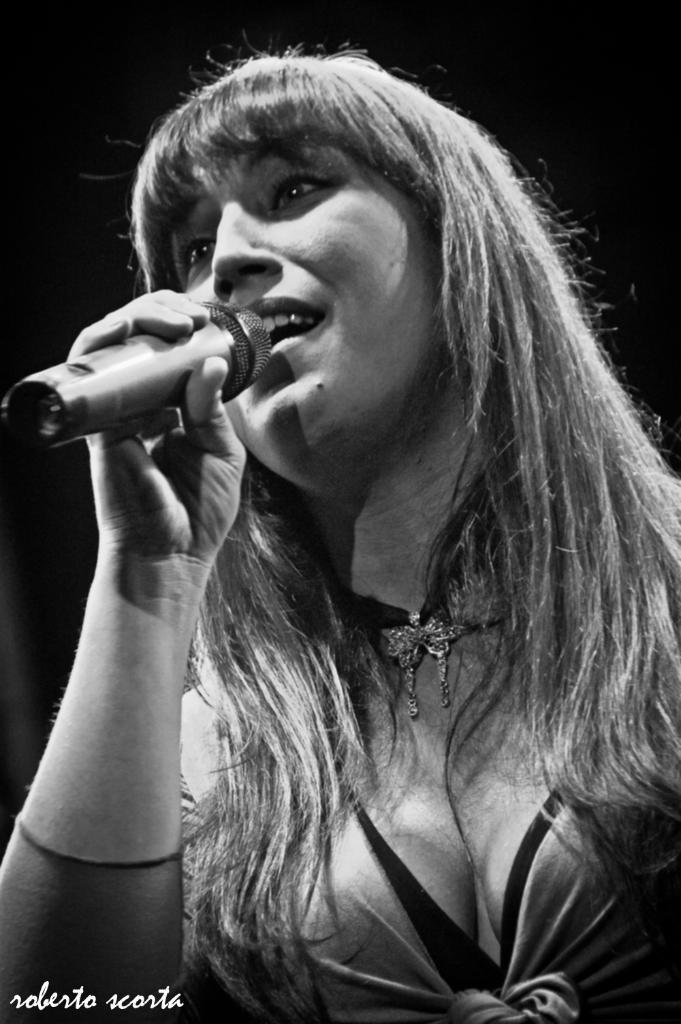Who is the main subject in the image? There is a woman in the image. What is the woman holding in the image? The woman is holding a microphone. What might the woman be doing with the microphone? The woman might be singing. How many baseball players can be seen in the image? There are no baseball players present in the image. Is there a rainstorm happening in the image? There is no indication of a rainstorm in the image. 